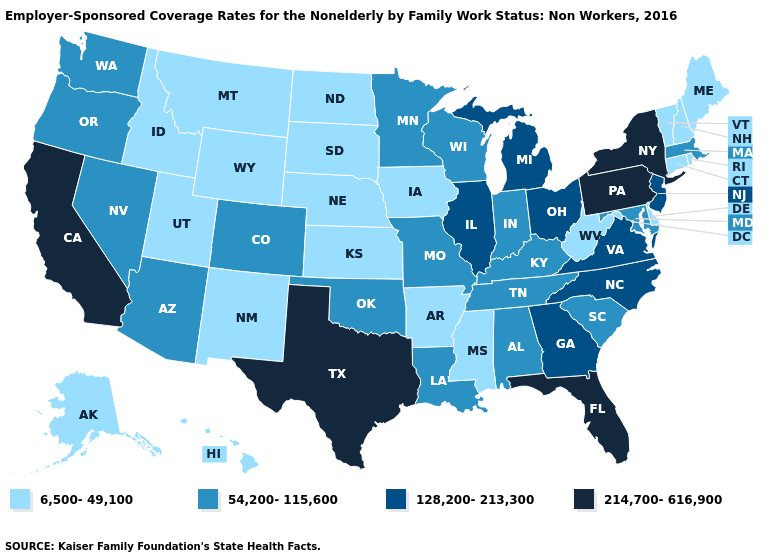What is the value of West Virginia?
Answer briefly. 6,500-49,100. Among the states that border Nebraska , does Colorado have the highest value?
Answer briefly. Yes. What is the value of New York?
Concise answer only. 214,700-616,900. Does Idaho have the highest value in the West?
Be succinct. No. What is the lowest value in the USA?
Concise answer only. 6,500-49,100. Name the states that have a value in the range 128,200-213,300?
Answer briefly. Georgia, Illinois, Michigan, New Jersey, North Carolina, Ohio, Virginia. What is the value of Kansas?
Answer briefly. 6,500-49,100. What is the lowest value in the USA?
Keep it brief. 6,500-49,100. Name the states that have a value in the range 6,500-49,100?
Short answer required. Alaska, Arkansas, Connecticut, Delaware, Hawaii, Idaho, Iowa, Kansas, Maine, Mississippi, Montana, Nebraska, New Hampshire, New Mexico, North Dakota, Rhode Island, South Dakota, Utah, Vermont, West Virginia, Wyoming. Does Wisconsin have the lowest value in the USA?
Quick response, please. No. What is the lowest value in states that border California?
Quick response, please. 54,200-115,600. What is the highest value in the USA?
Be succinct. 214,700-616,900. What is the value of Montana?
Write a very short answer. 6,500-49,100. Does the first symbol in the legend represent the smallest category?
Give a very brief answer. Yes. What is the value of Connecticut?
Concise answer only. 6,500-49,100. 